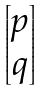<formula> <loc_0><loc_0><loc_500><loc_500>\begin{bmatrix} p \\ q \\ \end{bmatrix}</formula> 